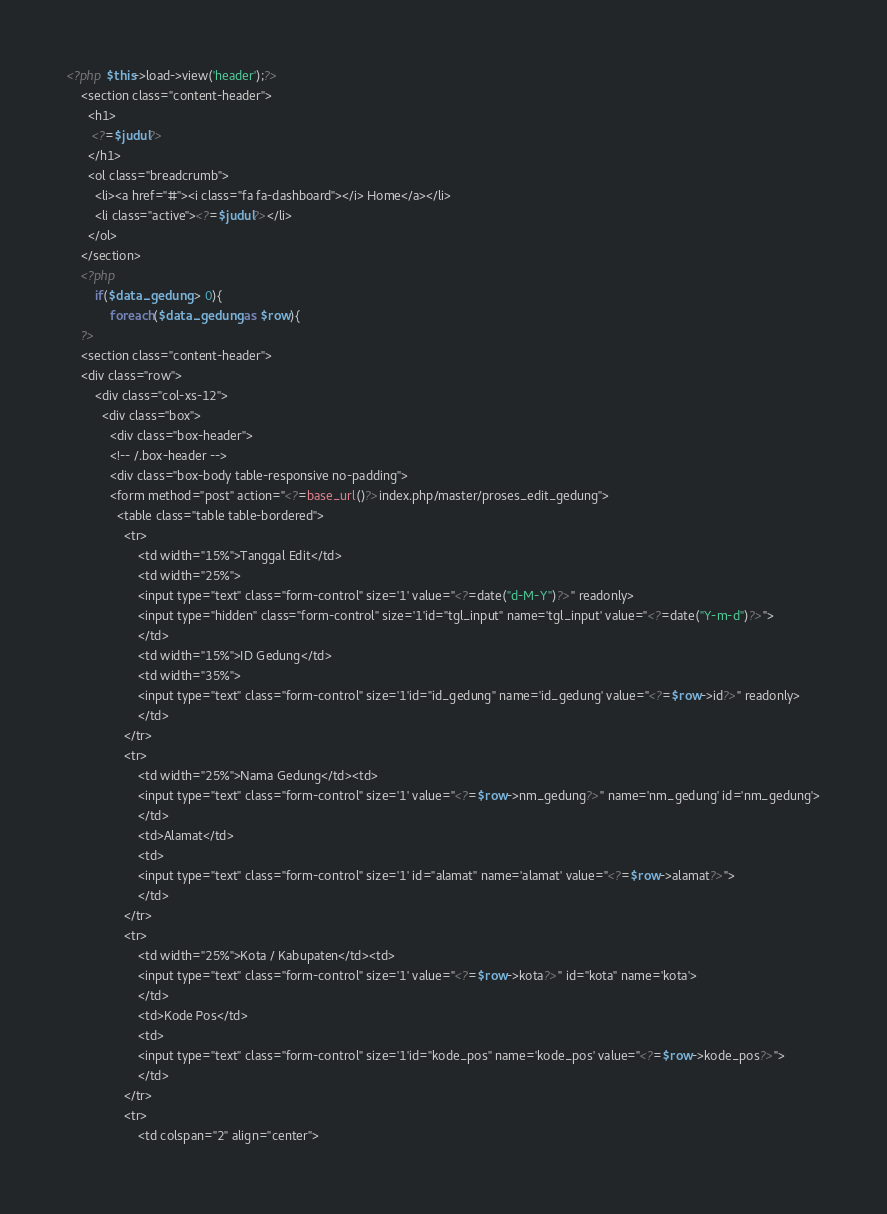Convert code to text. <code><loc_0><loc_0><loc_500><loc_500><_PHP_><?php $this->load->view('header');?>
    <section class="content-header">
      <h1>
       <?=$judul?>
      </h1>
      <ol class="breadcrumb">
        <li><a href="#"><i class="fa fa-dashboard"></i> Home</a></li>
        <li class="active"><?=$judul?></li>
      </ol>
    </section>
	<?php
		if($data_gedung > 0){
			foreach($data_gedung as $row){
	?>
	<section class="content-header">
    <div class="row">
        <div class="col-xs-12">
          <div class="box">
            <div class="box-header">
            <!-- /.box-header -->
            <div class="box-body table-responsive no-padding">
			<form method="post" action="<?=base_url()?>index.php/master/proses_edit_gedung">
              <table class="table table-bordered">
				<tr>
					<td width="15%">Tanggal Edit</td>
					<td width="25%">
					<input type="text" class="form-control" size='1' value="<?=date("d-M-Y")?>" readonly>
					<input type="hidden" class="form-control" size='1'id="tgl_input" name='tgl_input' value="<?=date("Y-m-d")?>">
					</td>
					<td width="15%">ID Gedung</td>
					<td width="35%">
					<input type="text" class="form-control" size='1'id="id_gedung" name='id_gedung' value="<?=$row->id?>" readonly>
					</td>
				</tr>
				<tr>
					<td width="25%">Nama Gedung</td><td>
					<input type="text" class="form-control" size='1' value="<?=$row->nm_gedung?>" name='nm_gedung' id='nm_gedung'>
					</td>
					<td>Alamat</td>
					<td>
					<input type="text" class="form-control" size='1' id="alamat" name='alamat' value="<?=$row->alamat?>">
					</td>
				</tr>
				<tr>
					<td width="25%">Kota / Kabupaten</td><td>
					<input type="text" class="form-control" size='1' value="<?=$row->kota?>" id="kota" name='kota'>
					</td>
					<td>Kode Pos</td>
					<td>
					<input type="text" class="form-control" size='1'id="kode_pos" name='kode_pos' value="<?=$row->kode_pos?>">
					</td>
				</tr>
				<tr>
					<td colspan="2" align="center"></code> 